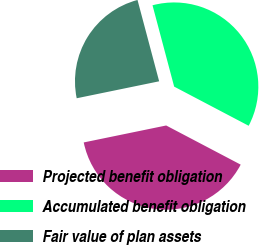<chart> <loc_0><loc_0><loc_500><loc_500><pie_chart><fcel>Projected benefit obligation<fcel>Accumulated benefit obligation<fcel>Fair value of plan assets<nl><fcel>39.07%<fcel>36.84%<fcel>24.09%<nl></chart> 